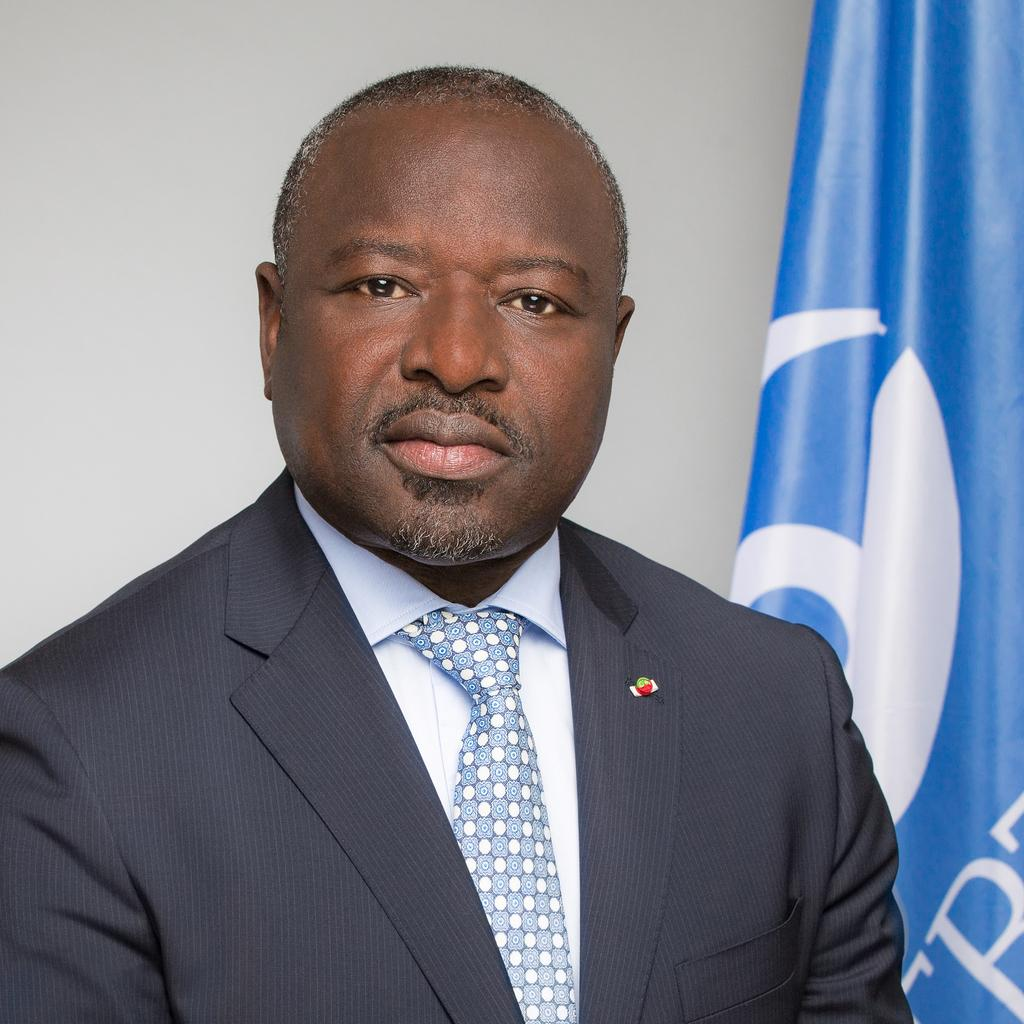What is the main subject of the image? There is a person in the image. What type of clothing is the person wearing? The person is wearing a blazer, a shirt, and a tie. What can be seen in the background of the image? There is a blue and white color flag and a wall in the background of the image. How many robins are perched on the person's shoulder in the image? There are no robins present in the image. What day of the week is depicted in the image? The image does not depict a specific day of the week. 